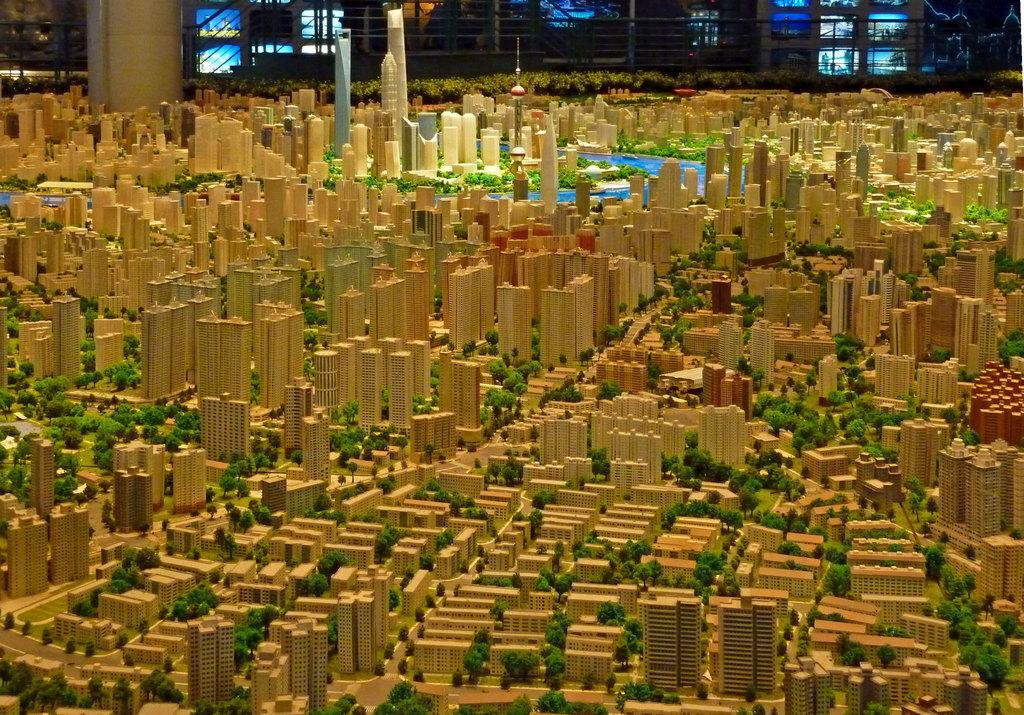What type of plan is depicted in the image? The image contains a plan of buildings. What architectural feature can be seen in the background of the image? There is a pillar in the background of the image. What type of display devices are visible in the image? There are screens visible in the image. What type of boot is being worn by the person in the image? There is no person present in the image, so it is not possible to determine what type of boot they might be wearing. 